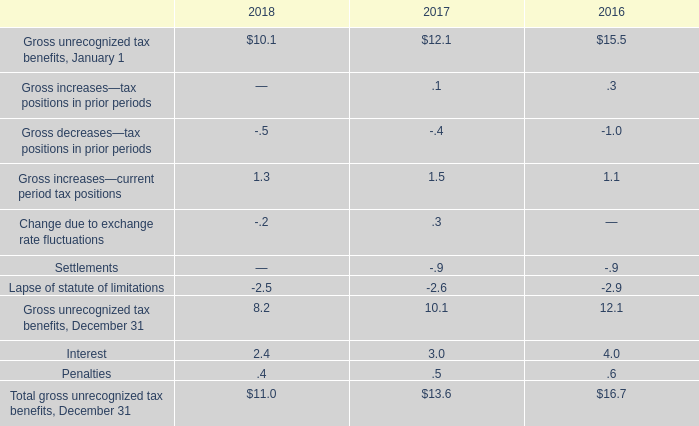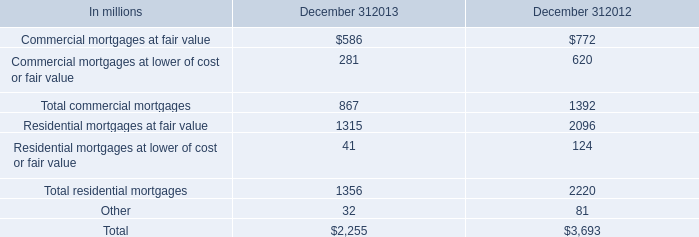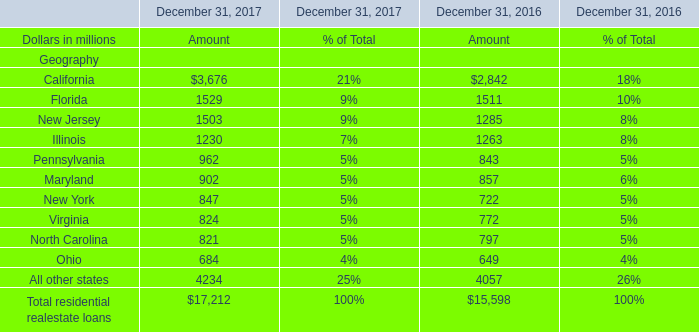What is the Amount of residential realestate loans at December 31, 2016 in terms of Illinois? (in million) 
Answer: 1263. 